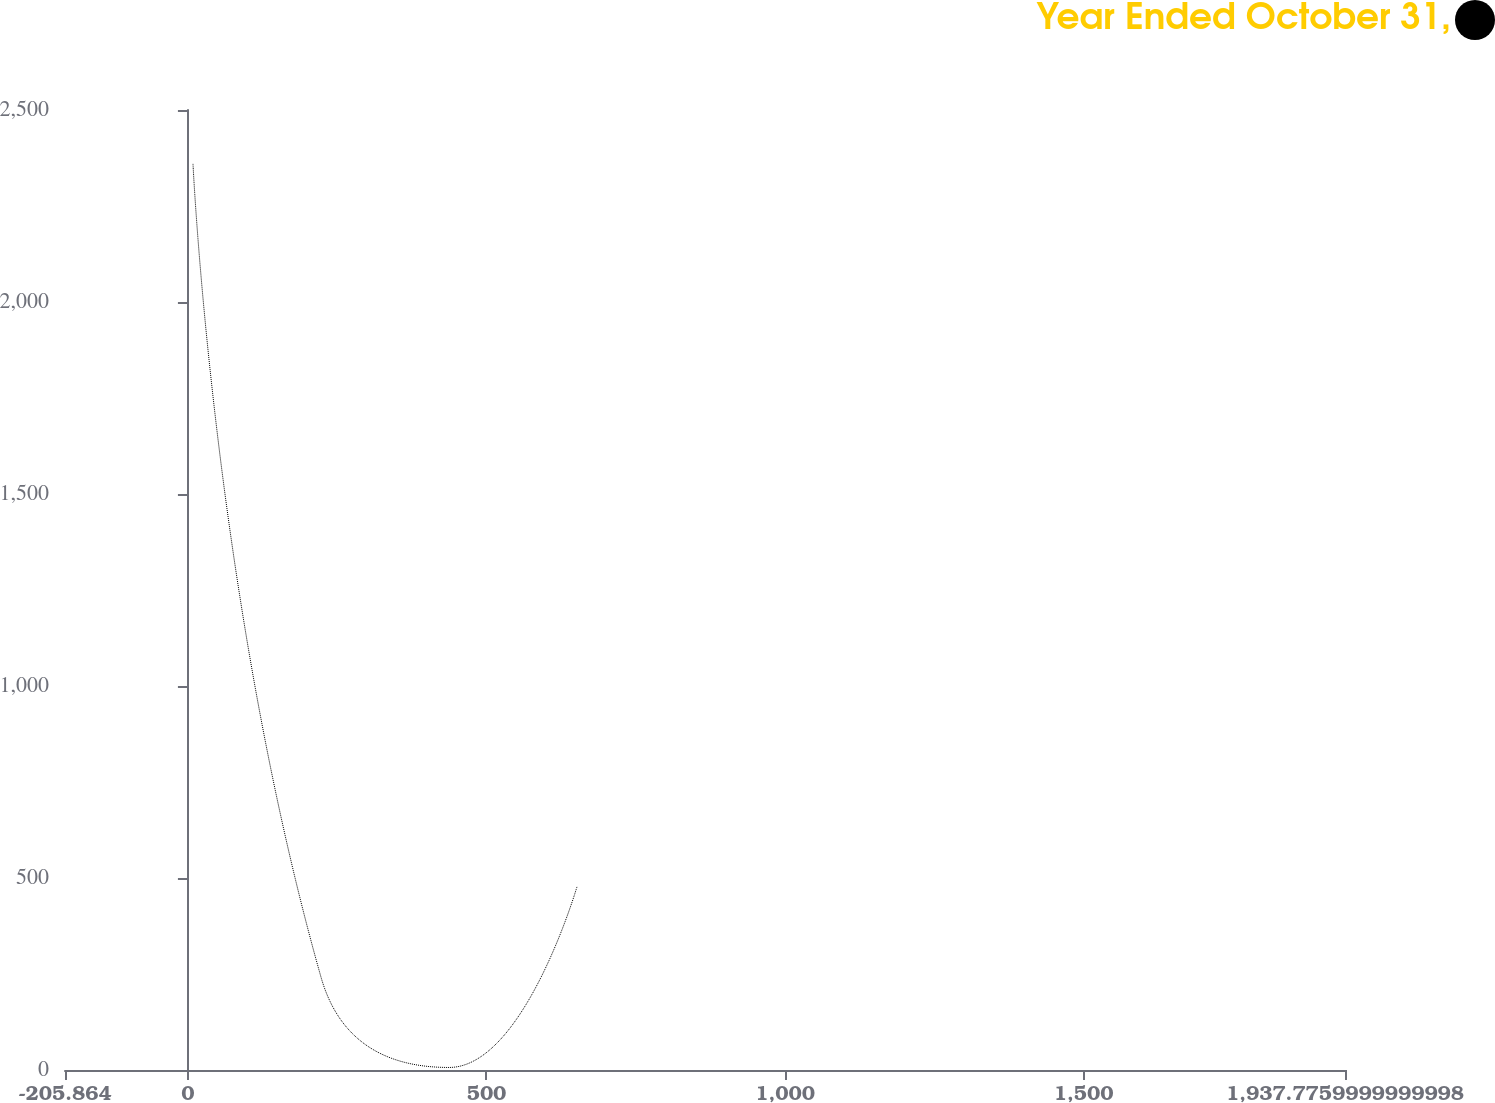Convert chart to OTSL. <chart><loc_0><loc_0><loc_500><loc_500><line_chart><ecel><fcel>Year Ended October 31,<nl><fcel>8.5<fcel>2359.68<nl><fcel>222.86<fcel>241.9<nl><fcel>437.22<fcel>6.59<nl><fcel>651.58<fcel>477.21<nl><fcel>2152.14<fcel>712.52<nl></chart> 